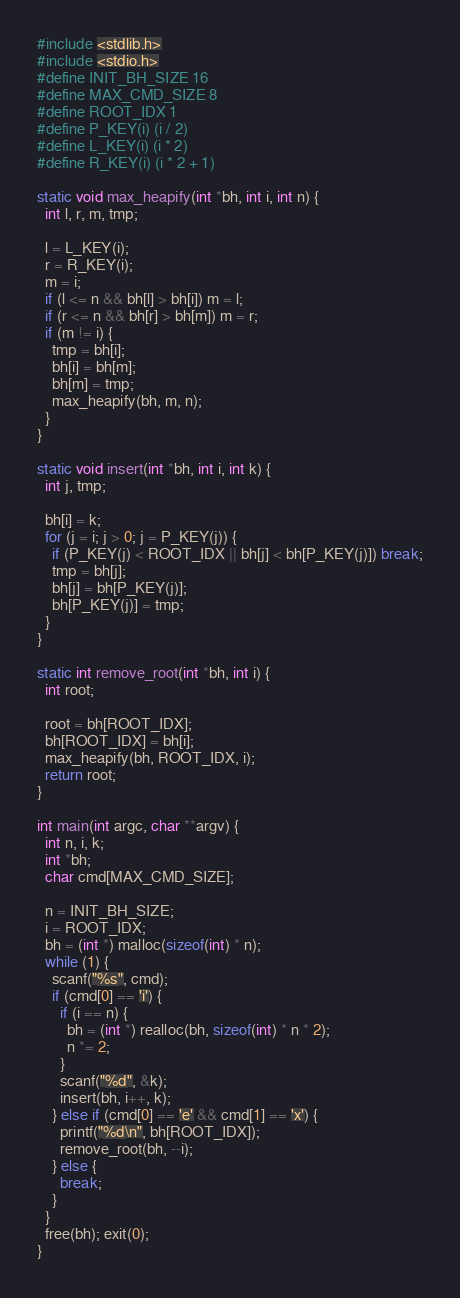Convert code to text. <code><loc_0><loc_0><loc_500><loc_500><_C_>#include <stdlib.h>
#include <stdio.h>    
#define INIT_BH_SIZE 16  
#define MAX_CMD_SIZE 8                          
#define ROOT_IDX 1                 
#define P_KEY(i) (i / 2)   
#define L_KEY(i) (i * 2)
#define R_KEY(i) (i * 2 + 1)
     
static void max_heapify(int *bh, int i, int n) {
  int l, r, m, tmp; 
 
  l = L_KEY(i);                            
  r = R_KEY(i);
  m = i;
  if (l <= n && bh[l] > bh[i]) m = l;
  if (r <= n && bh[r] > bh[m]) m = r;
  if (m != i) {
    tmp = bh[i];
    bh[i] = bh[m];
    bh[m] = tmp;
    max_heapify(bh, m, n);
  }
}

static void insert(int *bh, int i, int k) {
  int j, tmp;

  bh[i] = k;
  for (j = i; j > 0; j = P_KEY(j)) {
    if (P_KEY(j) < ROOT_IDX || bh[j] < bh[P_KEY(j)]) break;
    tmp = bh[j];
    bh[j] = bh[P_KEY(j)];
    bh[P_KEY(j)] = tmp;
  }
}

static int remove_root(int *bh, int i) {
  int root;

  root = bh[ROOT_IDX];
  bh[ROOT_IDX] = bh[i];
  max_heapify(bh, ROOT_IDX, i);
  return root;
}

int main(int argc, char **argv) {
  int n, i, k;
  int *bh;
  char cmd[MAX_CMD_SIZE];

  n = INIT_BH_SIZE;
  i = ROOT_IDX;
  bh = (int *) malloc(sizeof(int) * n);
  while (1) {
    scanf("%s", cmd);
    if (cmd[0] == 'i') {
      if (i == n) {
        bh = (int *) realloc(bh, sizeof(int) * n * 2);
        n *= 2;
      }
      scanf("%d", &k);
      insert(bh, i++, k);
    } else if (cmd[0] == 'e' && cmd[1] == 'x') {
      printf("%d\n", bh[ROOT_IDX]);
      remove_root(bh, --i);
    } else {
      break;
    }
  }
  free(bh); exit(0);
}
</code> 